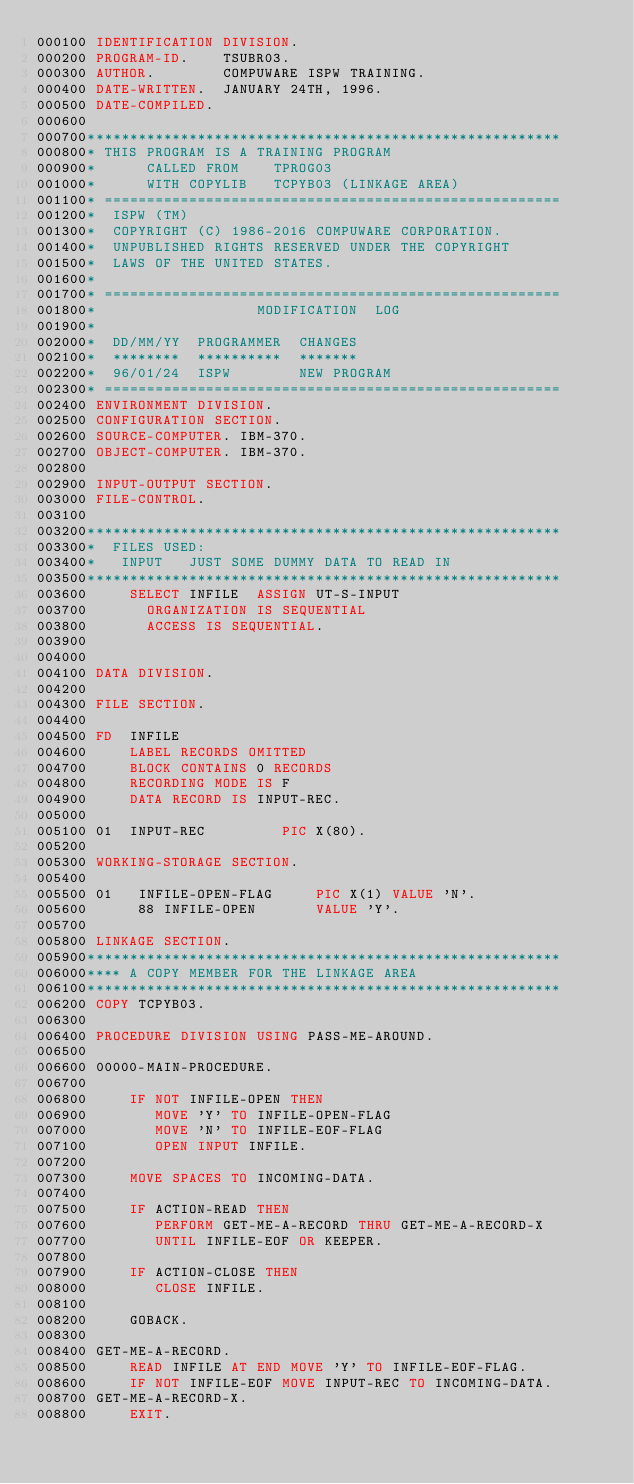Convert code to text. <code><loc_0><loc_0><loc_500><loc_500><_COBOL_>000100 IDENTIFICATION DIVISION.
000200 PROGRAM-ID.    TSUBR03.
000300 AUTHOR.        COMPUWARE ISPW TRAINING.
000400 DATE-WRITTEN.  JANUARY 24TH, 1996.
000500 DATE-COMPILED.
000600
000700********************************************************
000800* THIS PROGRAM IS A TRAINING PROGRAM
000900*      CALLED FROM    TPROG03
001000*      WITH COPYLIB   TCPYB03 (LINKAGE AREA)
001100* ======================================================
001200*  ISPW (TM)
001300*  COPYRIGHT (C) 1986-2016 COMPUWARE CORPORATION.
001400*  UNPUBLISHED RIGHTS RESERVED UNDER THE COPYRIGHT
001500*  LAWS OF THE UNITED STATES.
001600*
001700* ======================================================
001800*                   MODIFICATION  LOG
001900*
002000*  DD/MM/YY  PROGRAMMER  CHANGES
002100*  ********  **********  *******
002200*  96/01/24  ISPW        NEW PROGRAM
002300* ======================================================
002400 ENVIRONMENT DIVISION.
002500 CONFIGURATION SECTION.
002600 SOURCE-COMPUTER. IBM-370.
002700 OBJECT-COMPUTER. IBM-370.
002800
002900 INPUT-OUTPUT SECTION.
003000 FILE-CONTROL.
003100
003200********************************************************
003300*  FILES USED:
003400*   INPUT   JUST SOME DUMMY DATA TO READ IN
003500********************************************************
003600     SELECT INFILE  ASSIGN UT-S-INPUT
003700       ORGANIZATION IS SEQUENTIAL
003800       ACCESS IS SEQUENTIAL.
003900
004000
004100 DATA DIVISION.
004200
004300 FILE SECTION.
004400
004500 FD  INFILE
004600     LABEL RECORDS OMITTED
004700     BLOCK CONTAINS 0 RECORDS
004800     RECORDING MODE IS F
004900     DATA RECORD IS INPUT-REC.
005000
005100 01  INPUT-REC         PIC X(80).
005200
005300 WORKING-STORAGE SECTION.
005400
005500 01   INFILE-OPEN-FLAG     PIC X(1) VALUE 'N'.
005600      88 INFILE-OPEN       VALUE 'Y'.
005700
005800 LINKAGE SECTION.
005900********************************************************
006000**** A COPY MEMBER FOR THE LINKAGE AREA
006100********************************************************
006200 COPY TCPYB03.
006300
006400 PROCEDURE DIVISION USING PASS-ME-AROUND.
006500
006600 00000-MAIN-PROCEDURE.
006700
006800     IF NOT INFILE-OPEN THEN
006900        MOVE 'Y' TO INFILE-OPEN-FLAG
007000        MOVE 'N' TO INFILE-EOF-FLAG
007100        OPEN INPUT INFILE.
007200
007300     MOVE SPACES TO INCOMING-DATA.
007400
007500     IF ACTION-READ THEN
007600        PERFORM GET-ME-A-RECORD THRU GET-ME-A-RECORD-X
007700        UNTIL INFILE-EOF OR KEEPER.
007800
007900     IF ACTION-CLOSE THEN
008000        CLOSE INFILE.
008100
008200     GOBACK.
008300
008400 GET-ME-A-RECORD.
008500     READ INFILE AT END MOVE 'Y' TO INFILE-EOF-FLAG.
008600     IF NOT INFILE-EOF MOVE INPUT-REC TO INCOMING-DATA.
008700 GET-ME-A-RECORD-X.
008800     EXIT.</code> 